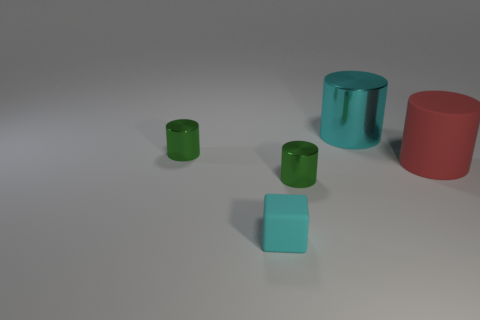Add 3 large rubber cylinders. How many objects exist? 8 Subtract all cyan cylinders. How many cylinders are left? 3 Subtract all green cylinders. How many cylinders are left? 2 Subtract all cylinders. How many objects are left? 1 Subtract 2 cylinders. How many cylinders are left? 2 Add 4 big cyan cylinders. How many big cyan cylinders exist? 5 Subtract 0 brown spheres. How many objects are left? 5 Subtract all brown cylinders. Subtract all blue balls. How many cylinders are left? 4 Subtract all blue cylinders. How many yellow cubes are left? 0 Subtract all tiny purple cylinders. Subtract all red rubber cylinders. How many objects are left? 4 